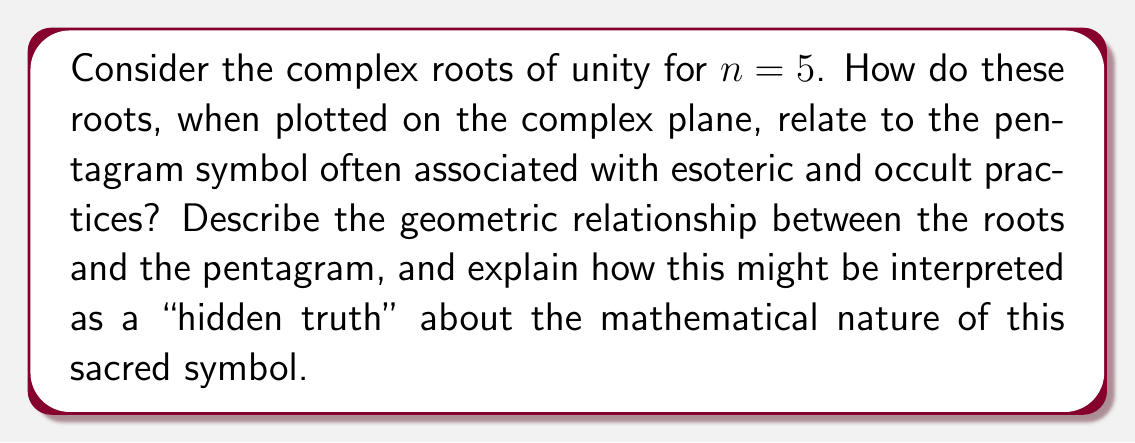What is the answer to this math problem? To analyze this, let's follow these steps:

1) The complex roots of unity for $n=5$ are given by the formula:
   $$z_k = e^{2\pi i k/5}, \quad k = 0, 1, 2, 3, 4$$

2) When plotted on the complex plane, these roots form a regular pentagon inscribed in the unit circle. The roots are:
   $$z_0 = 1$$
   $$z_1 = e^{2\pi i/5} \approx 0.309 + 0.951i$$
   $$z_2 = e^{4\pi i/5} \approx -0.809 + 0.588i$$
   $$z_3 = e^{6\pi i/5} \approx -0.809 - 0.588i$$
   $$z_4 = e^{8\pi i/5} \approx 0.309 - 0.951i$$

3) The pentagram can be constructed by connecting every second point of this pentagon. This creates a five-pointed star.

4) The relationship between the roots of unity and the pentagram reveals several "hidden truths":

   a) The golden ratio, $\phi = (1+\sqrt{5})/2$, appears in the pentagram. The ratio of the length of a longer segment to a shorter segment in the pentagram is exactly $\phi$.

   b) The angle between any two adjacent points in the pentagram is $36°$, which is $1/10$ of a full circle. This connects to the decimal system and the base-10 number system.

   c) The pentagram can be infinitely nested within itself, creating a fractal-like pattern that suggests infinite recursion and self-similarity.

5) From an esoteric perspective, these mathematical properties could be interpreted as evidence of divine design or cosmic order embedded in this sacred symbol.

[asy]
import geometry;

unitcircle();
pair[] z = new pair[5];
for(int k=0; k<5; ++k) {
  z[k] = exp(2pi*I*k/5);
  dot(z[k]);
}

draw(z[0]--z[2]--z[4]--z[1]--z[3]--z[0], red);
draw(z[0]--z[1]--z[2]--z[3]--z[4]--z[0], blue);

label("$z_0$", z[0], E);
label("$z_1$", z[1], NE);
label("$z_2$", z[2], NW);
label("$z_3$", z[3], SW);
label("$z_4$", z[4], SE);
[/asy]
Answer: The 5th roots of unity, when plotted, form a regular pentagon. Connecting every second point of this pentagon creates a perfect pentagram. This reveals the inherent connection between the mathematical concept of complex roots of unity and the sacred pentagram symbol. The pentagram formed exhibits the golden ratio and possesses properties of infinite self-similarity, which could be interpreted as a "hidden truth" about the mathematical and potentially divine nature of this symbol. 